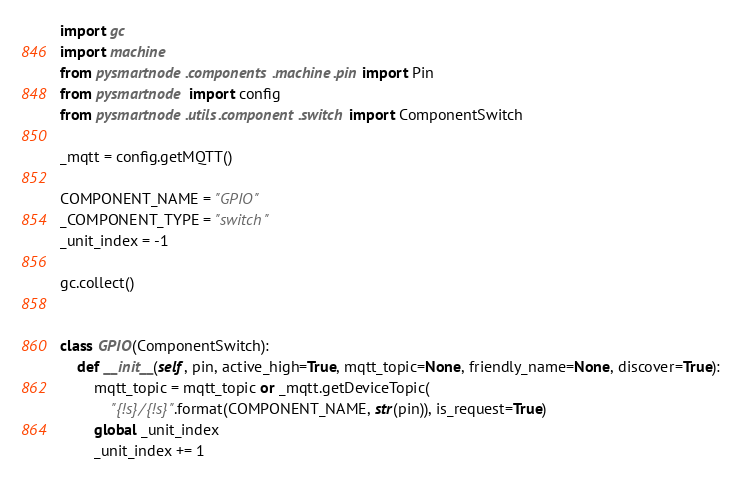Convert code to text. <code><loc_0><loc_0><loc_500><loc_500><_Python_>
import gc
import machine
from pysmartnode.components.machine.pin import Pin
from pysmartnode import config
from pysmartnode.utils.component.switch import ComponentSwitch

_mqtt = config.getMQTT()

COMPONENT_NAME = "GPIO"
_COMPONENT_TYPE = "switch"
_unit_index = -1

gc.collect()


class GPIO(ComponentSwitch):
    def __init__(self, pin, active_high=True, mqtt_topic=None, friendly_name=None, discover=True):
        mqtt_topic = mqtt_topic or _mqtt.getDeviceTopic(
            "{!s}/{!s}".format(COMPONENT_NAME, str(pin)), is_request=True)
        global _unit_index
        _unit_index += 1</code> 